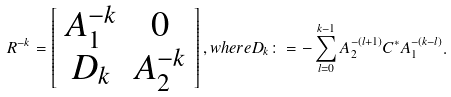<formula> <loc_0><loc_0><loc_500><loc_500>R ^ { - k } = \left [ \begin{array} { c c } A _ { 1 } ^ { - k } & 0 \\ D _ { k } & A _ { 2 } ^ { - k } \end{array} \right ] , w h e r e D _ { k } \colon = - \sum _ { l = 0 } ^ { k - 1 } A _ { 2 } ^ { - ( l + 1 ) } C ^ { * } A _ { 1 } ^ { - ( k - l ) } .</formula> 